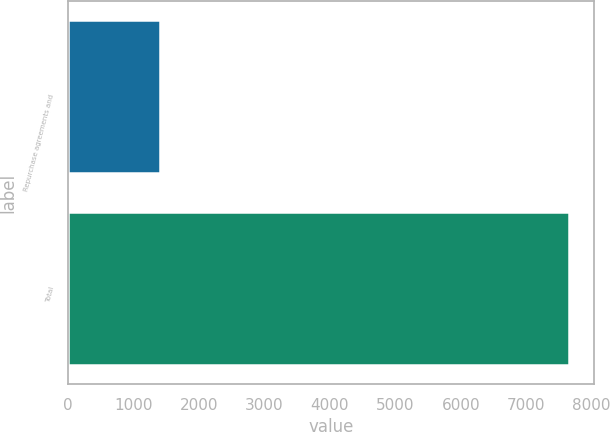Convert chart to OTSL. <chart><loc_0><loc_0><loc_500><loc_500><bar_chart><fcel>Repurchase agreements and<fcel>Total<nl><fcel>1406<fcel>7659<nl></chart> 